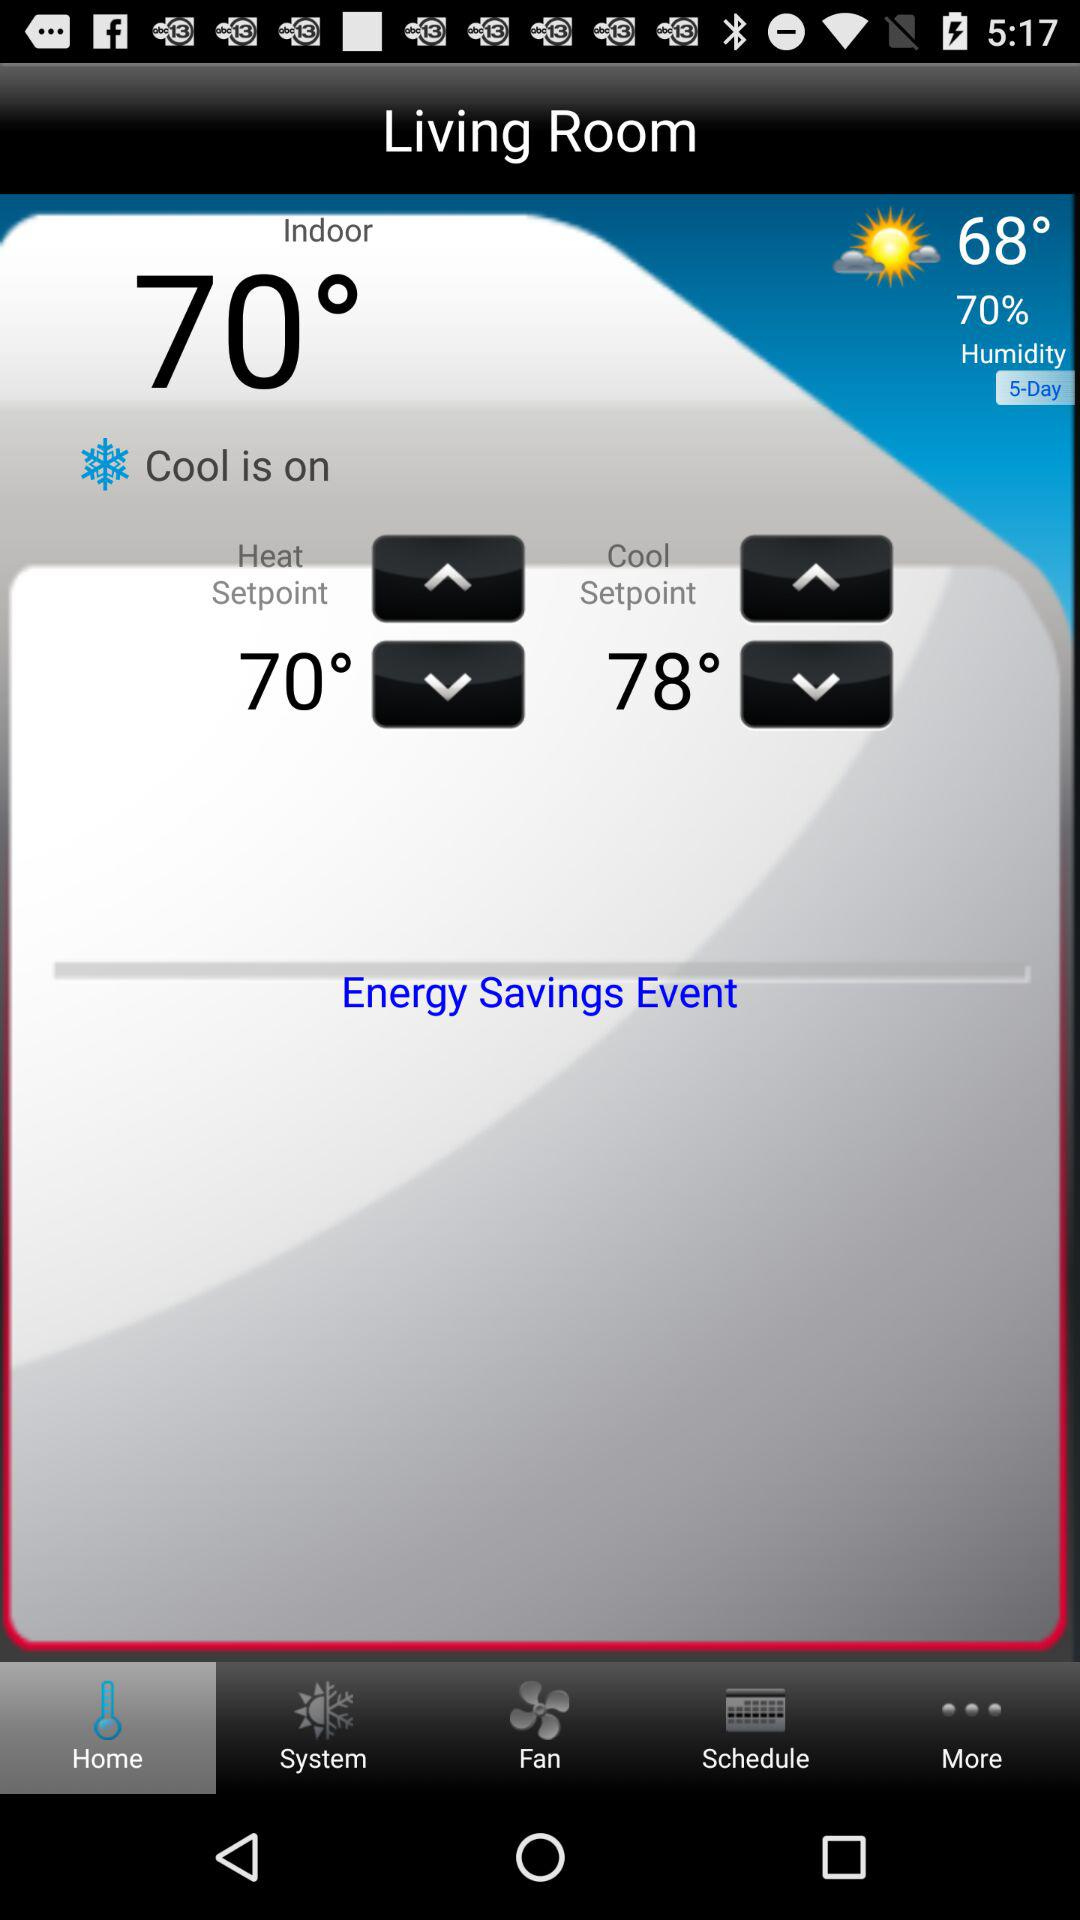What kind of weather are we having?
When the provided information is insufficient, respond with <no answer>. <no answer> 